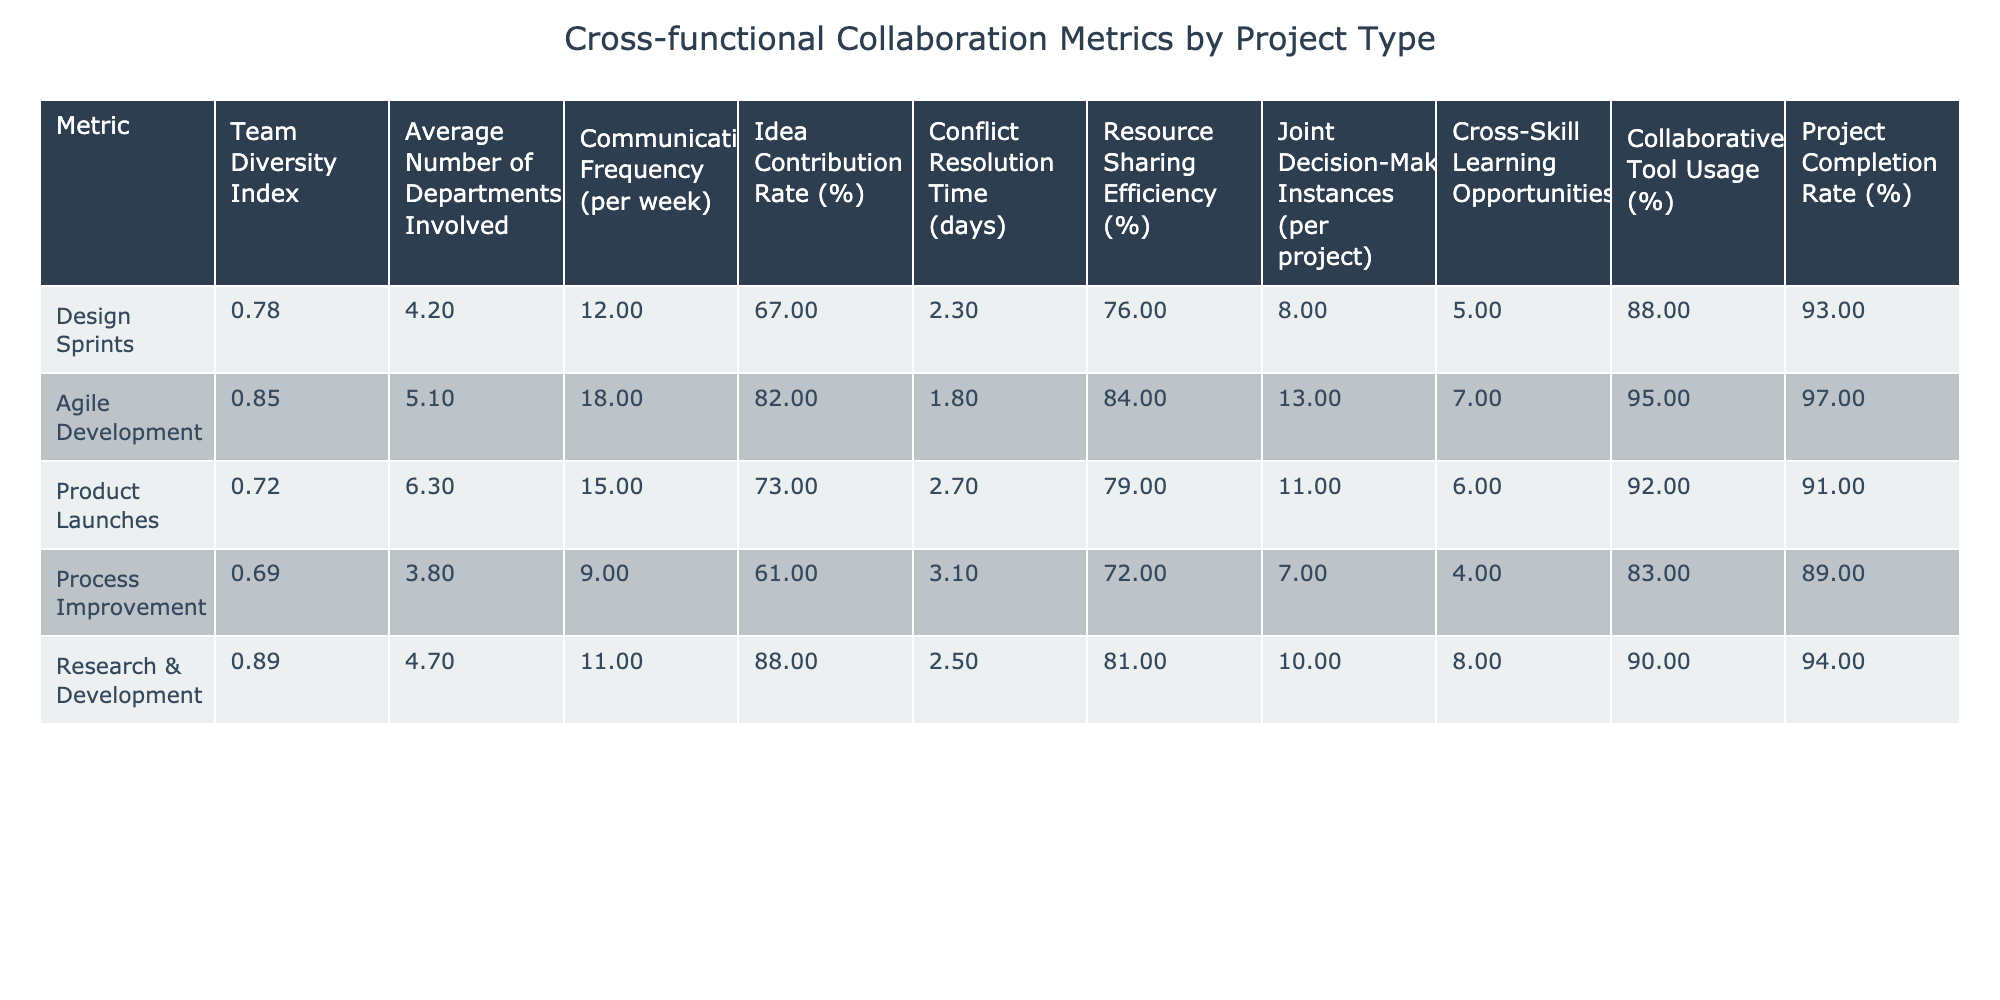What is the Team Diversity Index for Agile Development? The Team Diversity Index for Agile Development is directly listed in the table under that project type. By checking the corresponding value, we see it is 0.85.
Answer: 0.85 How many departments are typically involved in Product Launches? The table specifies that the Average Number of Departments Involved in Product Launches is listed under that category, which shows a value of 6.3.
Answer: 6.3 What is the Conflict Resolution Time for Process Improvement projects? By examining the table, the Conflict Resolution Time for Process Improvement is found directly listed, which is 3.1 days.
Answer: 3.1 days Which project type has the highest Idea Contribution Rate? The table shows the Idea Contribution Rates for all project types. The highest value among these is 88%, which corresponds to Research & Development.
Answer: Research & Development What is the average Communication Frequency across all project types? To find the average Communication Frequency, sum the values (12 + 18 + 15 + 9 + 11) = 65. Then divide by the number of project types, which is 5. Thus, the average is 65/5 = 13.
Answer: 13 Is the Resource Sharing Efficiency for Design Sprints higher than 80%? Checking the table, the Resource Sharing Efficiency for Design Sprints is recorded as 76%, which is not higher than 80%. Therefore, the statement is false.
Answer: No What is the difference in Joint Decision-Making Instances between Agile Development and Process Improvement? Looking at the table, the Joint Decision-Making Instances for Agile Development is 13 and for Process Improvement is 7. The difference is 13 - 7 = 6.
Answer: 6 Which project type has the lowest Project Completion Rate? The Project Completion Rates are compared from the table. Process Improvement shows the lowest rate at 89%.
Answer: Process Improvement How many more Cross-Skill Learning Opportunities are there in Research & Development than in Process Improvement? The Cross-Skill Learning Opportunities for Research & Development is 8, and for Process Improvement, it is 4. The difference is 8 - 4 = 4.
Answer: 4 What percentage of Collaborative Tool Usage is seen in Agile Development? The table indicates directly that the percentage of Collaborative Tool Usage for Agile Development is 95%.
Answer: 95% Which project type has the most frequent communication, and what is its frequency? Checking the Communication Frequency values in the table, Agile Development has the highest frequency at 18 communications per week.
Answer: Agile Development, 18 